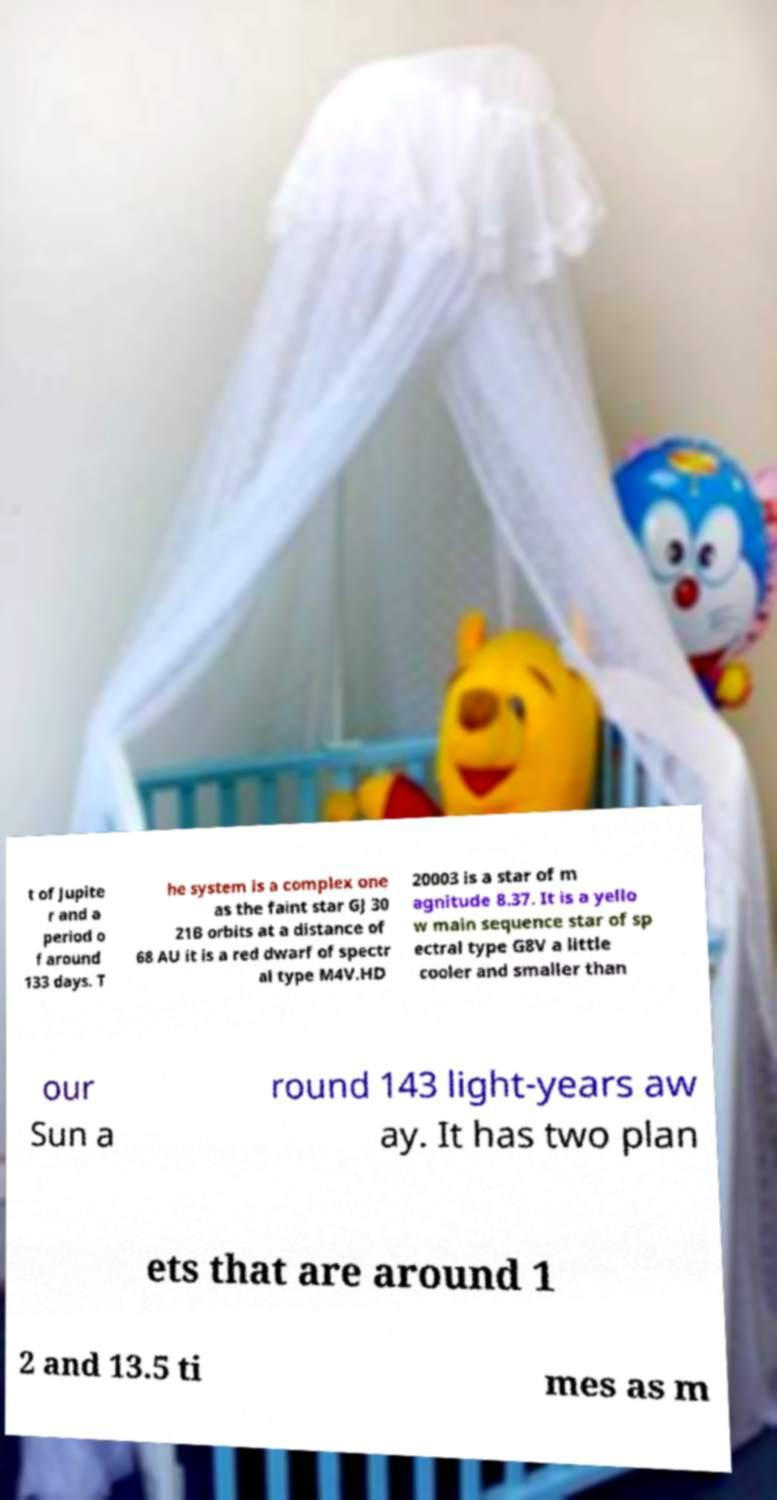Please identify and transcribe the text found in this image. t of Jupite r and a period o f around 133 days. T he system is a complex one as the faint star GJ 30 21B orbits at a distance of 68 AU it is a red dwarf of spectr al type M4V.HD 20003 is a star of m agnitude 8.37. It is a yello w main sequence star of sp ectral type G8V a little cooler and smaller than our Sun a round 143 light-years aw ay. It has two plan ets that are around 1 2 and 13.5 ti mes as m 